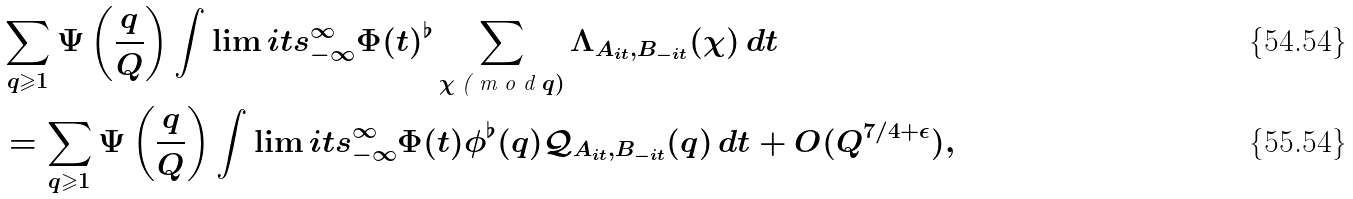Convert formula to latex. <formula><loc_0><loc_0><loc_500><loc_500>& \sum _ { q \geqslant 1 } \Psi \left ( \frac { q } { Q } \right ) \int \lim i t s _ { - \infty } ^ { \infty } \Phi ( t ) { ^ { \flat } } \sum _ { \chi \emph { ( m o d } q ) } \Lambda _ { A _ { i t } , B _ { - i t } } ( \chi ) \, d t \\ & = \sum _ { q \geqslant 1 } \Psi \left ( \frac { q } { Q } \right ) \int \lim i t s _ { - \infty } ^ { \infty } \Phi ( t ) \phi ^ { \flat } ( q ) \mathcal { Q } _ { A _ { i t } , B _ { - i t } } ( q ) \, d t + O ( Q ^ { 7 / 4 + \epsilon } ) ,</formula> 